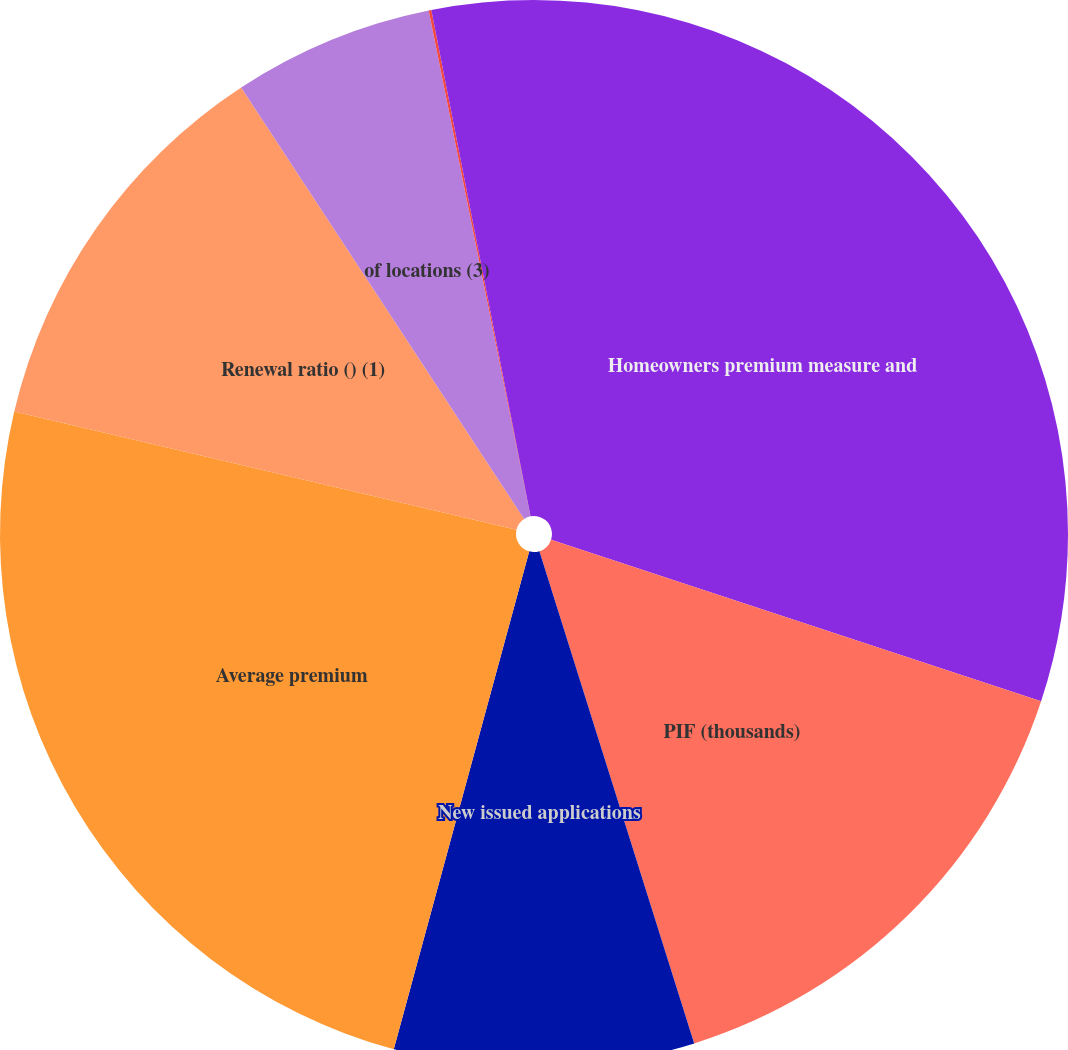Convert chart. <chart><loc_0><loc_0><loc_500><loc_500><pie_chart><fcel>Homeowners premium measure and<fcel>PIF (thousands)<fcel>New issued applications<fcel>Average premium<fcel>Renewal ratio () (1)<fcel>of locations (3)<fcel>Total brand ()<fcel>Location specific () (4)<nl><fcel>30.08%<fcel>15.08%<fcel>9.08%<fcel>24.46%<fcel>12.08%<fcel>6.08%<fcel>0.08%<fcel>3.08%<nl></chart> 